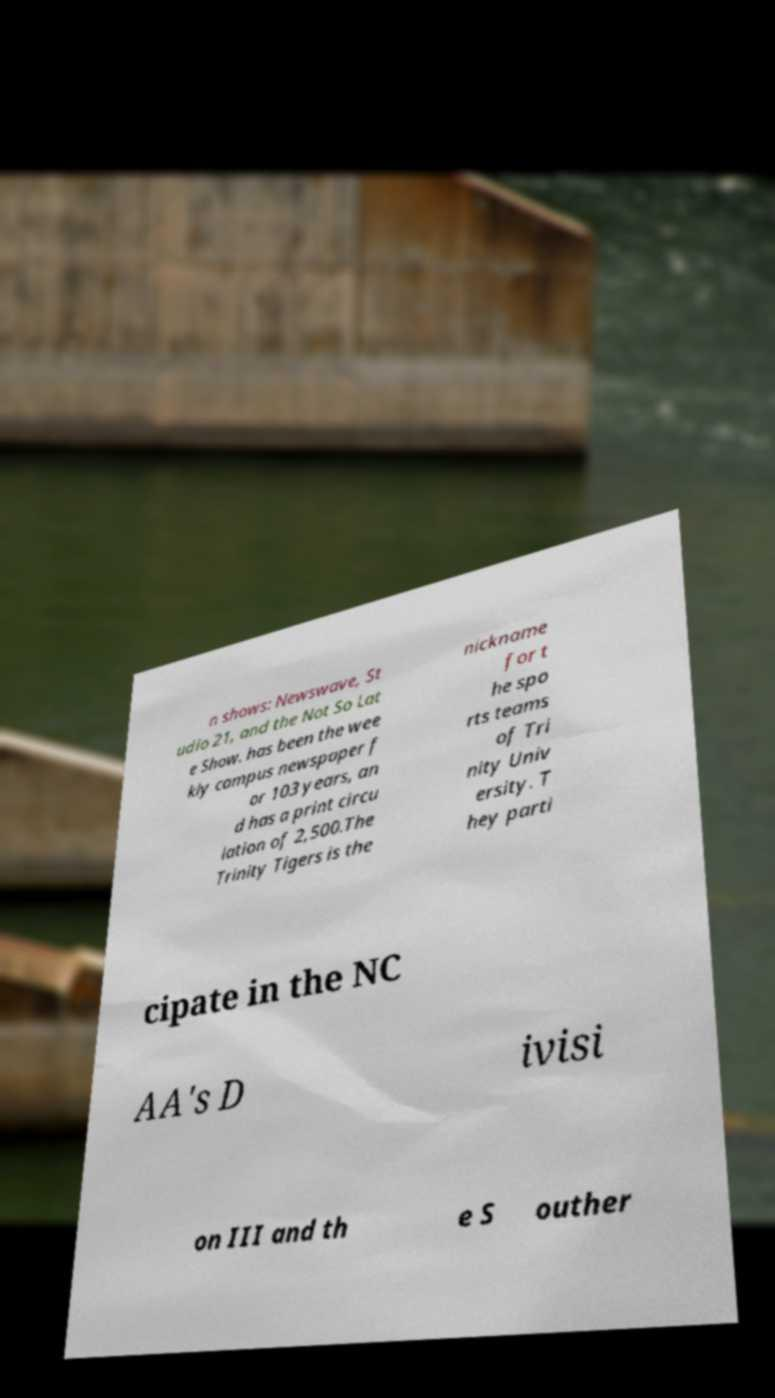Could you extract and type out the text from this image? n shows: Newswave, St udio 21, and the Not So Lat e Show. has been the wee kly campus newspaper f or 103 years, an d has a print circu lation of 2,500.The Trinity Tigers is the nickname for t he spo rts teams of Tri nity Univ ersity. T hey parti cipate in the NC AA's D ivisi on III and th e S outher 